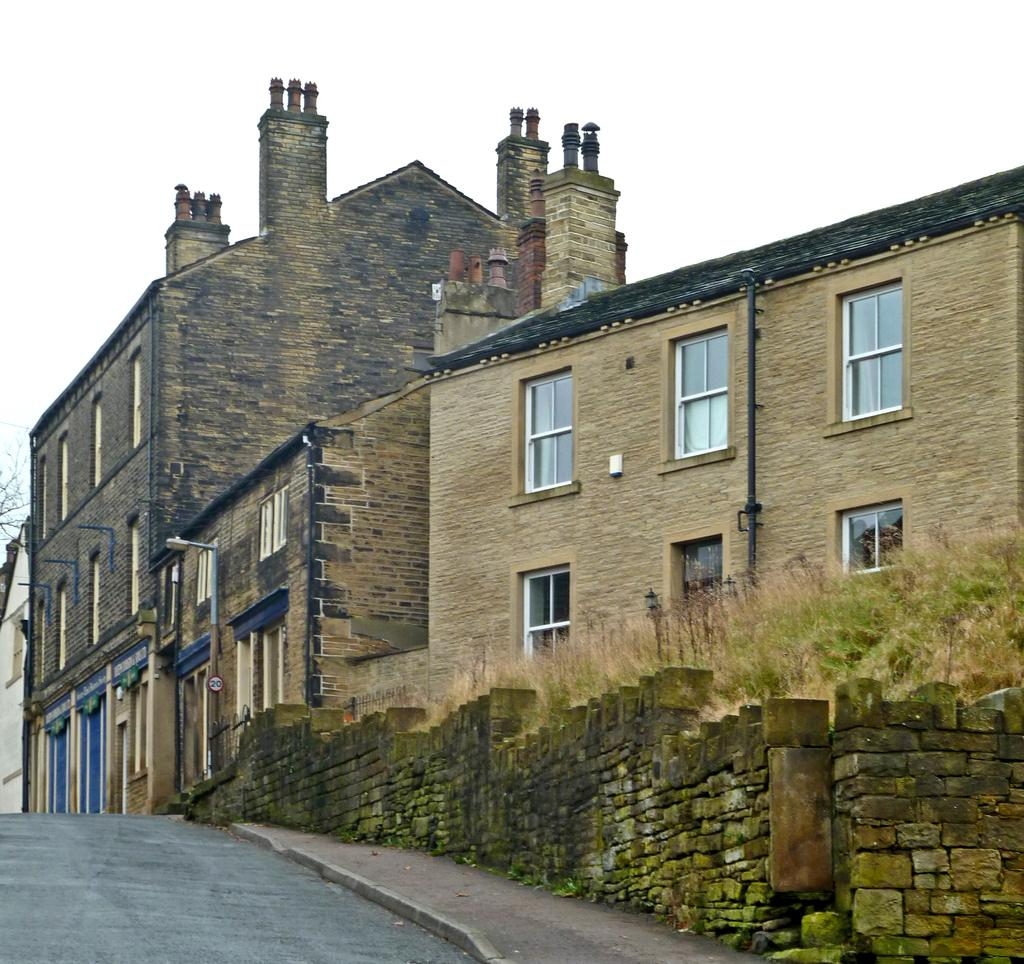What is the main feature of the image? There is a road in the image. What structure is located near the road? There is a house beside the road. What objects can be seen along the road? There are poles in the image. What type of barrier is present in the image? There is a small wall in the image. What type of vegetation is near the house? There is grass near the house. How many mice are playing with the babies in the image? There are no mice or babies present in the image. What type of range is visible in the image? There is no range visible in the image. 